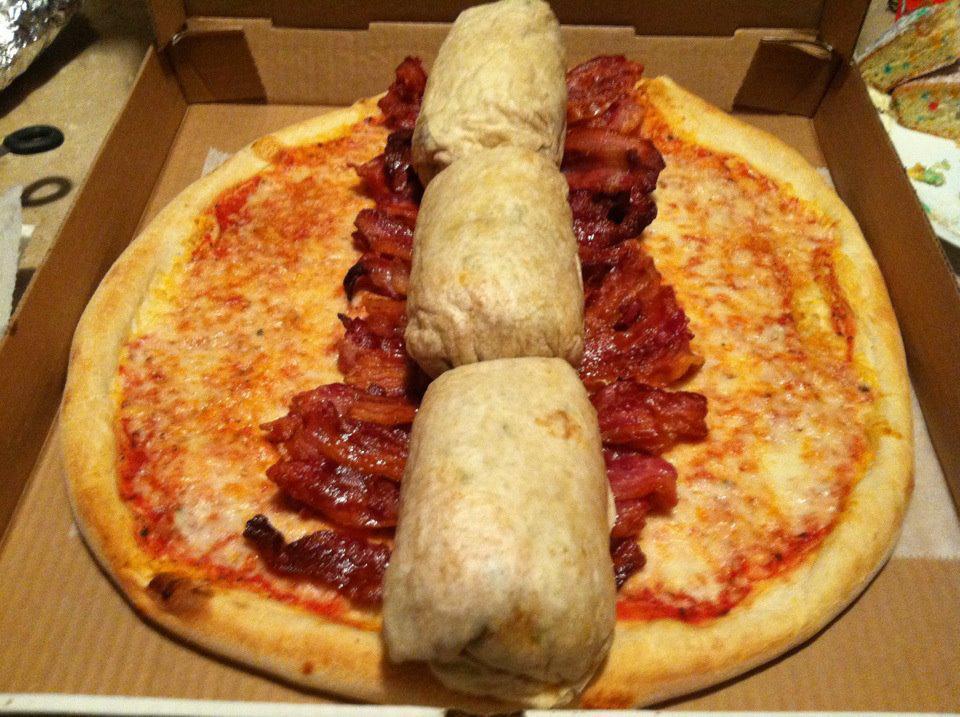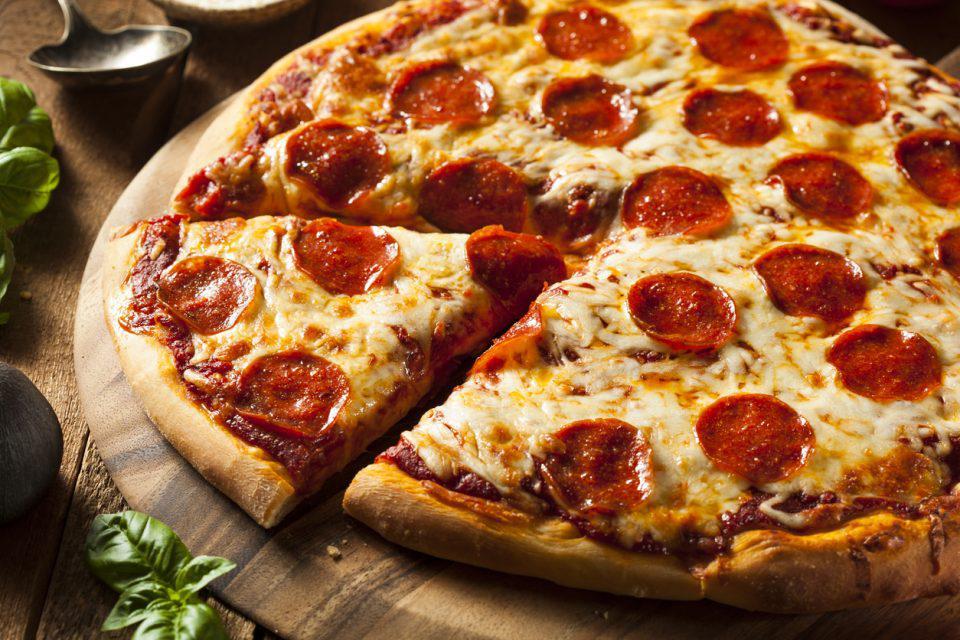The first image is the image on the left, the second image is the image on the right. Given the left and right images, does the statement "A pizza is topped with burgers, fries and nuggets." hold true? Answer yes or no. No. The first image is the image on the left, the second image is the image on the right. Given the left and right images, does the statement "One of the pizzas has hamburgers on top." hold true? Answer yes or no. No. 